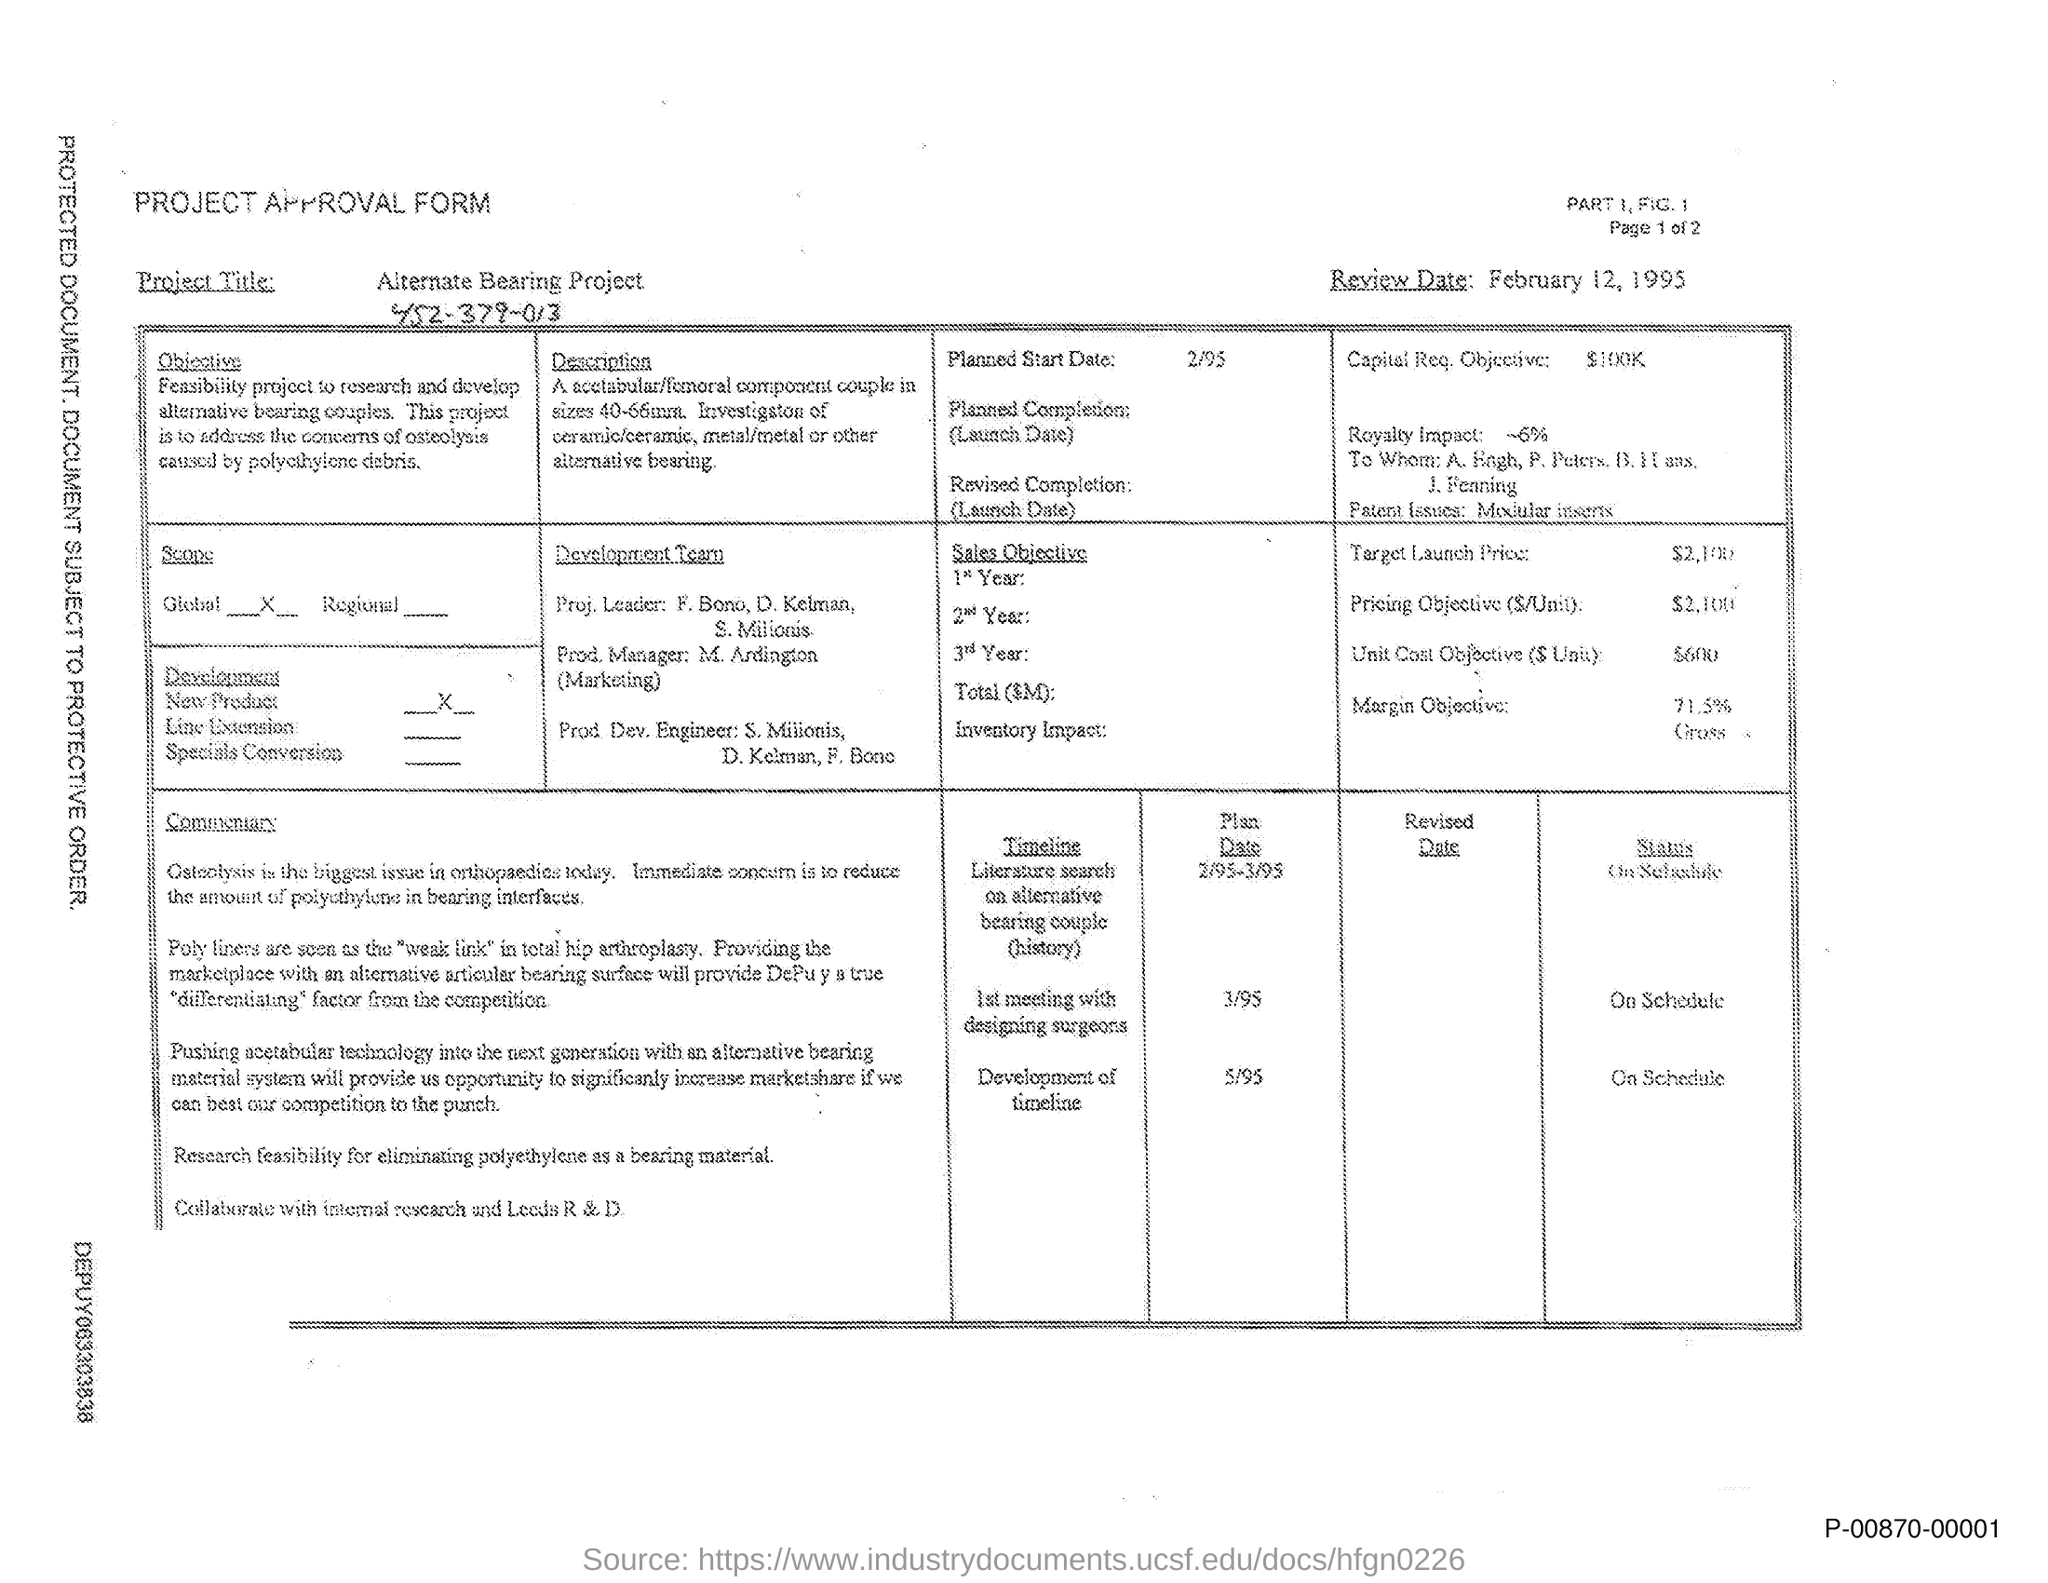Mention a couple of crucial points in this snapshot. The project approval form is a type of form that is given here. The Alternate Bearing Project is the title of the project as provided in the form. The planned start date of the project is 2/95. The Capital Req. Objective is given in the form of "$100K...". The development team has leaders from the project, including F. Bono, D. Kelman, and S. Milionis. 